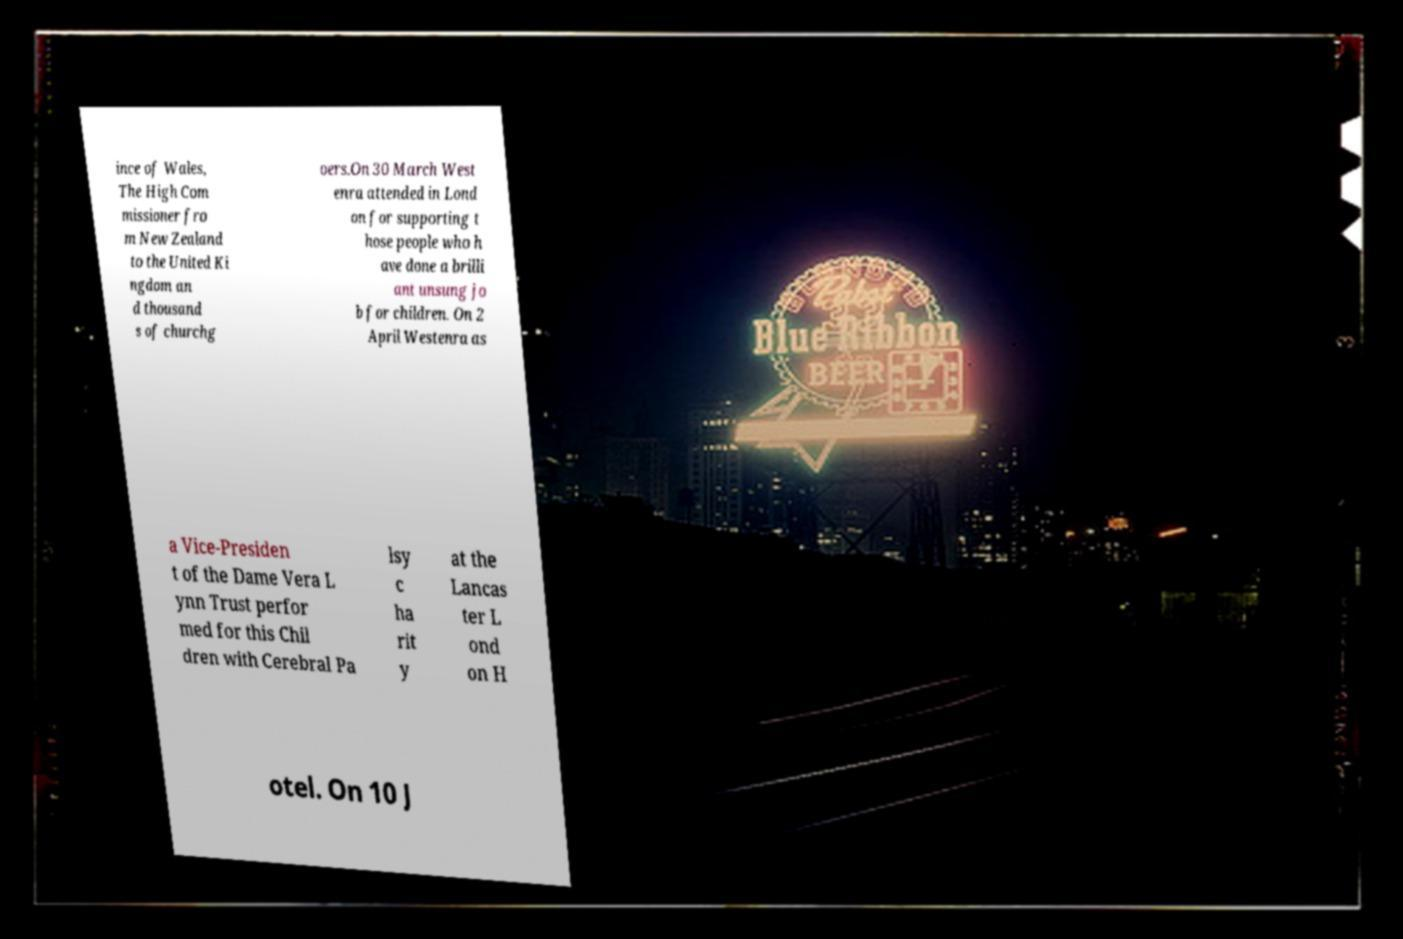There's text embedded in this image that I need extracted. Can you transcribe it verbatim? ince of Wales, The High Com missioner fro m New Zealand to the United Ki ngdom an d thousand s of churchg oers.On 30 March West enra attended in Lond on for supporting t hose people who h ave done a brilli ant unsung jo b for children. On 2 April Westenra as a Vice-Presiden t of the Dame Vera L ynn Trust perfor med for this Chil dren with Cerebral Pa lsy c ha rit y at the Lancas ter L ond on H otel. On 10 J 